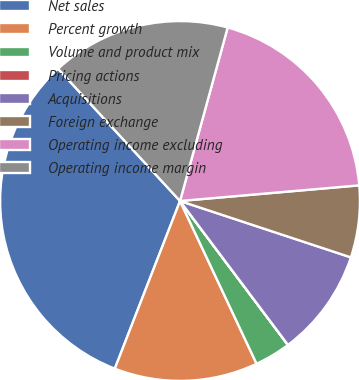Convert chart. <chart><loc_0><loc_0><loc_500><loc_500><pie_chart><fcel>Net sales<fcel>Percent growth<fcel>Volume and product mix<fcel>Pricing actions<fcel>Acquisitions<fcel>Foreign exchange<fcel>Operating income excluding<fcel>Operating income margin<nl><fcel>32.24%<fcel>12.9%<fcel>3.24%<fcel>0.01%<fcel>9.68%<fcel>6.46%<fcel>19.35%<fcel>16.12%<nl></chart> 